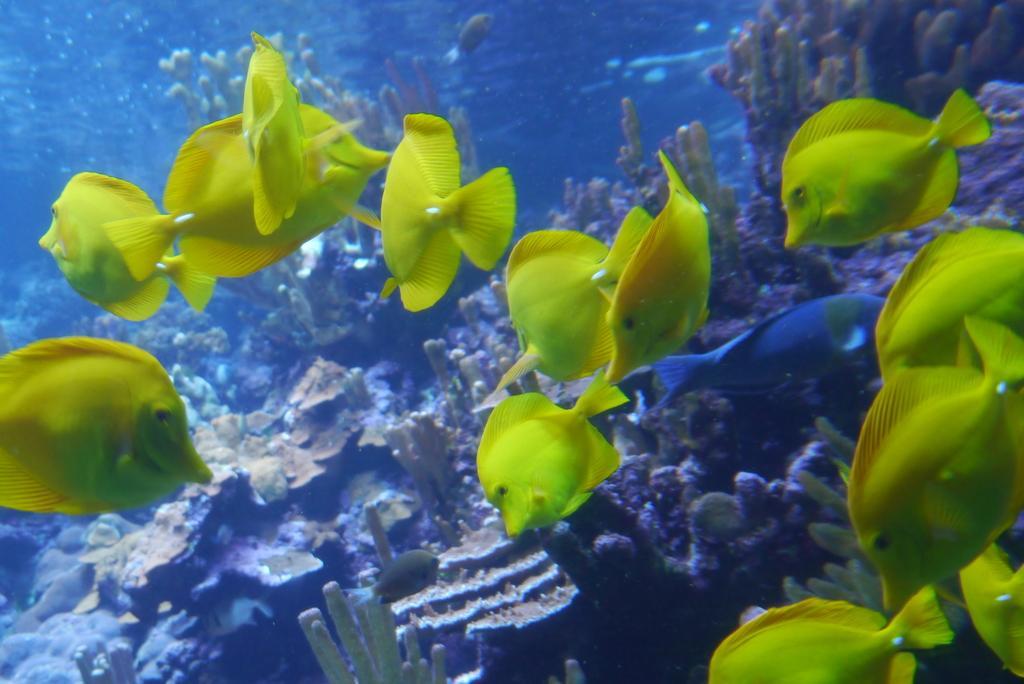Please provide a concise description of this image. In this picture there are fishes and there are marine plants in the water. 